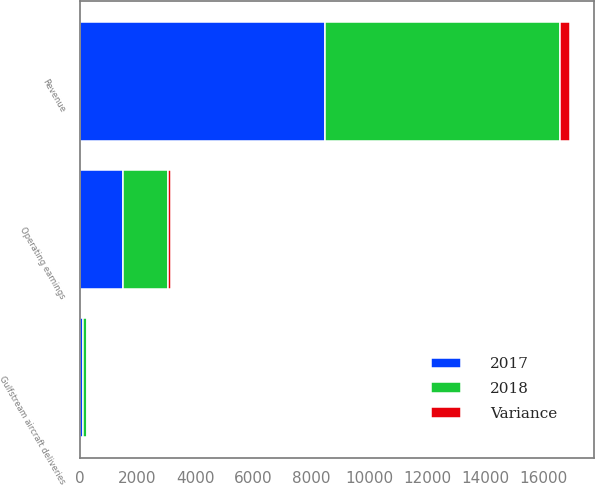Convert chart to OTSL. <chart><loc_0><loc_0><loc_500><loc_500><stacked_bar_chart><ecel><fcel>Revenue<fcel>Operating earnings<fcel>Gulfstream aircraft deliveries<nl><fcel>2017<fcel>8455<fcel>1490<fcel>121<nl><fcel>2018<fcel>8129<fcel>1577<fcel>120<nl><fcel>Variance<fcel>326<fcel>87<fcel>1<nl></chart> 